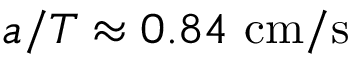<formula> <loc_0><loc_0><loc_500><loc_500>a / T \approx 0 . 8 4 c m / s</formula> 